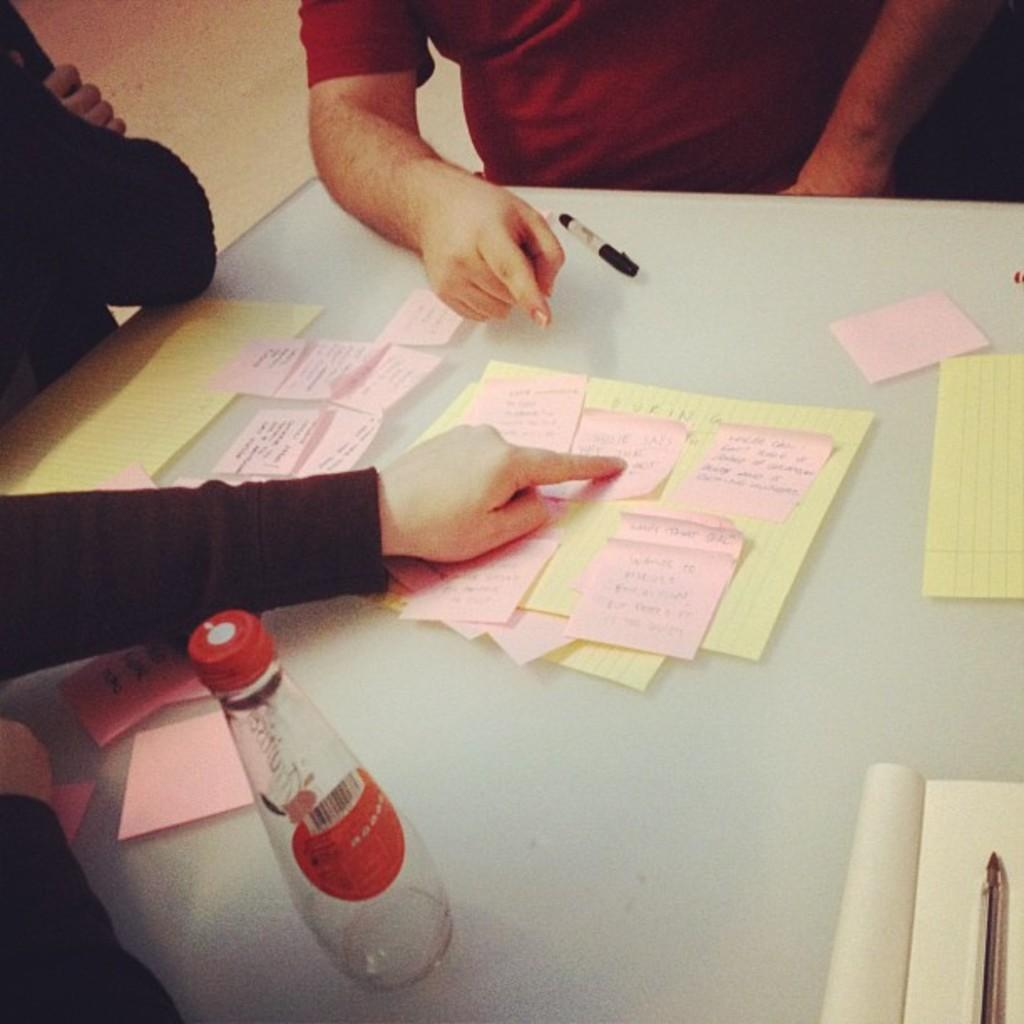What is in the center of the image? There is a table in the middle of the image. What objects can be seen on the table? There is a bottle, a paper, a book, and a pen on the table. What is the man in the image wearing? The man in the image is wearing a red t-shirt. Where is the person located in the image? There is a person on the left side of the image. What type of stone is being used to build the jail in the image? There is no jail present in the image, so it is not possible to determine what type of stone is being used. 